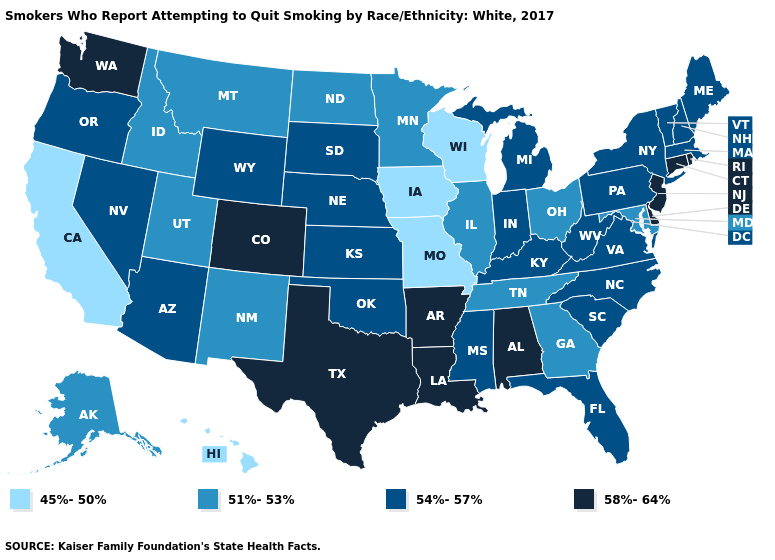What is the value of Missouri?
Concise answer only. 45%-50%. Does Illinois have a higher value than Texas?
Give a very brief answer. No. Which states have the lowest value in the USA?
Write a very short answer. California, Hawaii, Iowa, Missouri, Wisconsin. Does Nebraska have the same value as Wyoming?
Quick response, please. Yes. How many symbols are there in the legend?
Answer briefly. 4. Name the states that have a value in the range 58%-64%?
Answer briefly. Alabama, Arkansas, Colorado, Connecticut, Delaware, Louisiana, New Jersey, Rhode Island, Texas, Washington. What is the value of Colorado?
Answer briefly. 58%-64%. Among the states that border Mississippi , does Tennessee have the lowest value?
Give a very brief answer. Yes. Name the states that have a value in the range 45%-50%?
Quick response, please. California, Hawaii, Iowa, Missouri, Wisconsin. Among the states that border Nebraska , which have the lowest value?
Concise answer only. Iowa, Missouri. What is the value of Kentucky?
Short answer required. 54%-57%. Does the first symbol in the legend represent the smallest category?
Concise answer only. Yes. Does North Dakota have the highest value in the MidWest?
Keep it brief. No. Does Maryland have a lower value than Iowa?
Give a very brief answer. No. Name the states that have a value in the range 54%-57%?
Concise answer only. Arizona, Florida, Indiana, Kansas, Kentucky, Maine, Massachusetts, Michigan, Mississippi, Nebraska, Nevada, New Hampshire, New York, North Carolina, Oklahoma, Oregon, Pennsylvania, South Carolina, South Dakota, Vermont, Virginia, West Virginia, Wyoming. 